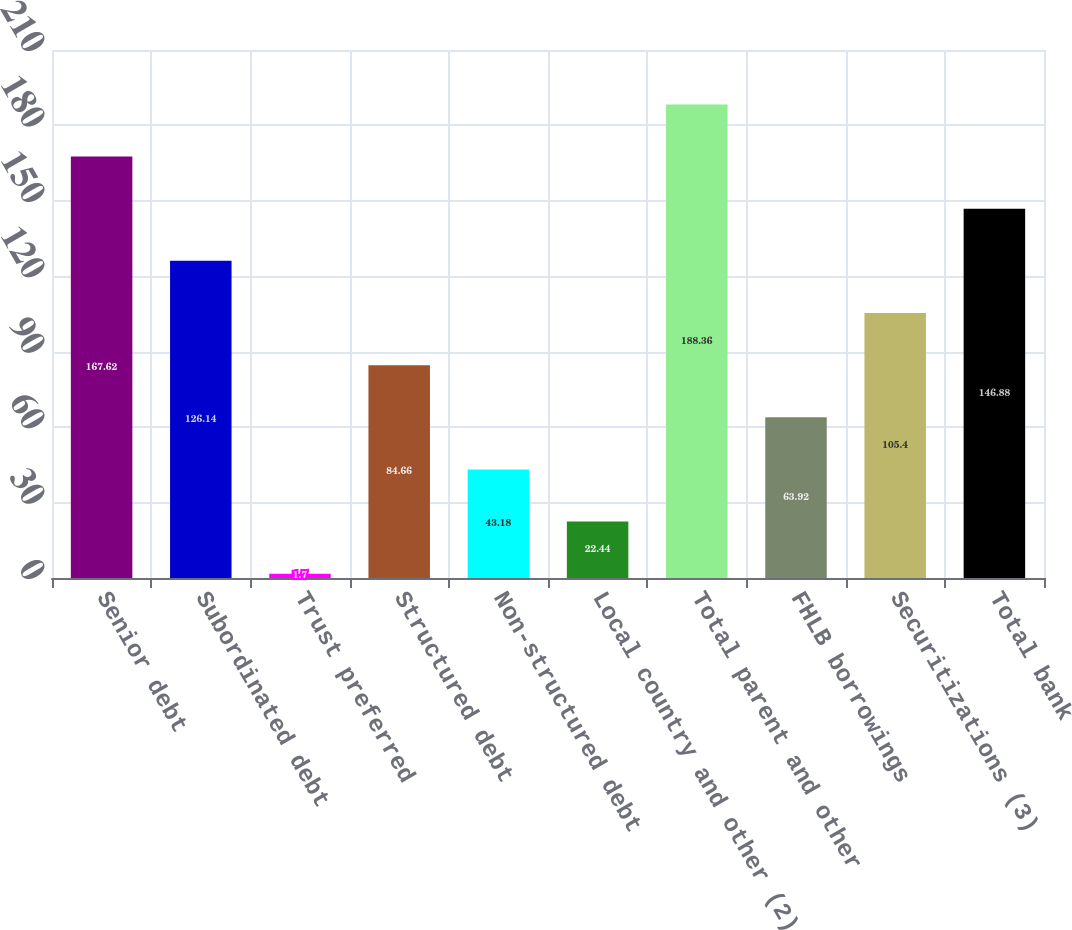<chart> <loc_0><loc_0><loc_500><loc_500><bar_chart><fcel>Senior debt<fcel>Subordinated debt<fcel>Trust preferred<fcel>Structured debt<fcel>Non-structured debt<fcel>Local country and other (2)<fcel>Total parent and other<fcel>FHLB borrowings<fcel>Securitizations (3)<fcel>Total bank<nl><fcel>167.62<fcel>126.14<fcel>1.7<fcel>84.66<fcel>43.18<fcel>22.44<fcel>188.36<fcel>63.92<fcel>105.4<fcel>146.88<nl></chart> 